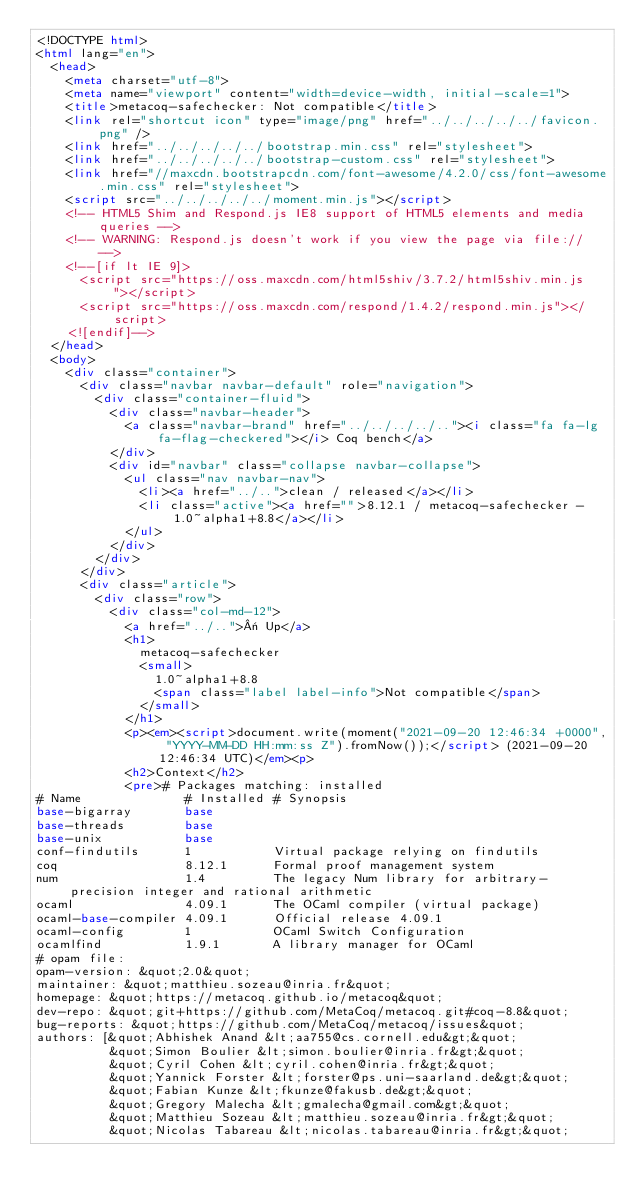Convert code to text. <code><loc_0><loc_0><loc_500><loc_500><_HTML_><!DOCTYPE html>
<html lang="en">
  <head>
    <meta charset="utf-8">
    <meta name="viewport" content="width=device-width, initial-scale=1">
    <title>metacoq-safechecker: Not compatible</title>
    <link rel="shortcut icon" type="image/png" href="../../../../../favicon.png" />
    <link href="../../../../../bootstrap.min.css" rel="stylesheet">
    <link href="../../../../../bootstrap-custom.css" rel="stylesheet">
    <link href="//maxcdn.bootstrapcdn.com/font-awesome/4.2.0/css/font-awesome.min.css" rel="stylesheet">
    <script src="../../../../../moment.min.js"></script>
    <!-- HTML5 Shim and Respond.js IE8 support of HTML5 elements and media queries -->
    <!-- WARNING: Respond.js doesn't work if you view the page via file:// -->
    <!--[if lt IE 9]>
      <script src="https://oss.maxcdn.com/html5shiv/3.7.2/html5shiv.min.js"></script>
      <script src="https://oss.maxcdn.com/respond/1.4.2/respond.min.js"></script>
    <![endif]-->
  </head>
  <body>
    <div class="container">
      <div class="navbar navbar-default" role="navigation">
        <div class="container-fluid">
          <div class="navbar-header">
            <a class="navbar-brand" href="../../../../.."><i class="fa fa-lg fa-flag-checkered"></i> Coq bench</a>
          </div>
          <div id="navbar" class="collapse navbar-collapse">
            <ul class="nav navbar-nav">
              <li><a href="../..">clean / released</a></li>
              <li class="active"><a href="">8.12.1 / metacoq-safechecker - 1.0~alpha1+8.8</a></li>
            </ul>
          </div>
        </div>
      </div>
      <div class="article">
        <div class="row">
          <div class="col-md-12">
            <a href="../..">« Up</a>
            <h1>
              metacoq-safechecker
              <small>
                1.0~alpha1+8.8
                <span class="label label-info">Not compatible</span>
              </small>
            </h1>
            <p><em><script>document.write(moment("2021-09-20 12:46:34 +0000", "YYYY-MM-DD HH:mm:ss Z").fromNow());</script> (2021-09-20 12:46:34 UTC)</em><p>
            <h2>Context</h2>
            <pre># Packages matching: installed
# Name              # Installed # Synopsis
base-bigarray       base
base-threads        base
base-unix           base
conf-findutils      1           Virtual package relying on findutils
coq                 8.12.1      Formal proof management system
num                 1.4         The legacy Num library for arbitrary-precision integer and rational arithmetic
ocaml               4.09.1      The OCaml compiler (virtual package)
ocaml-base-compiler 4.09.1      Official release 4.09.1
ocaml-config        1           OCaml Switch Configuration
ocamlfind           1.9.1       A library manager for OCaml
# opam file:
opam-version: &quot;2.0&quot;
maintainer: &quot;matthieu.sozeau@inria.fr&quot;
homepage: &quot;https://metacoq.github.io/metacoq&quot;
dev-repo: &quot;git+https://github.com/MetaCoq/metacoq.git#coq-8.8&quot;
bug-reports: &quot;https://github.com/MetaCoq/metacoq/issues&quot;
authors: [&quot;Abhishek Anand &lt;aa755@cs.cornell.edu&gt;&quot;
          &quot;Simon Boulier &lt;simon.boulier@inria.fr&gt;&quot;
          &quot;Cyril Cohen &lt;cyril.cohen@inria.fr&gt;&quot;
          &quot;Yannick Forster &lt;forster@ps.uni-saarland.de&gt;&quot;
          &quot;Fabian Kunze &lt;fkunze@fakusb.de&gt;&quot;
          &quot;Gregory Malecha &lt;gmalecha@gmail.com&gt;&quot;
          &quot;Matthieu Sozeau &lt;matthieu.sozeau@inria.fr&gt;&quot;
          &quot;Nicolas Tabareau &lt;nicolas.tabareau@inria.fr&gt;&quot;</code> 